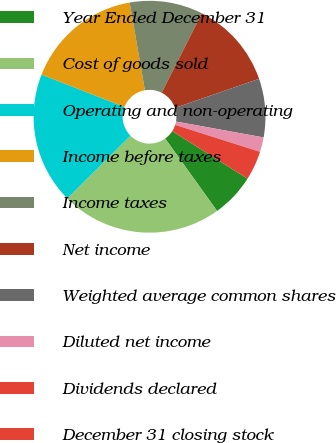Convert chart to OTSL. <chart><loc_0><loc_0><loc_500><loc_500><pie_chart><fcel>Year Ended December 31<fcel>Cost of goods sold<fcel>Operating and non-operating<fcel>Income before taxes<fcel>Income taxes<fcel>Net income<fcel>Weighted average common shares<fcel>Diluted net income<fcel>Dividends declared<fcel>December 31 closing stock<nl><fcel>6.12%<fcel>22.45%<fcel>18.37%<fcel>16.33%<fcel>10.2%<fcel>12.24%<fcel>8.16%<fcel>2.04%<fcel>0.0%<fcel>4.08%<nl></chart> 